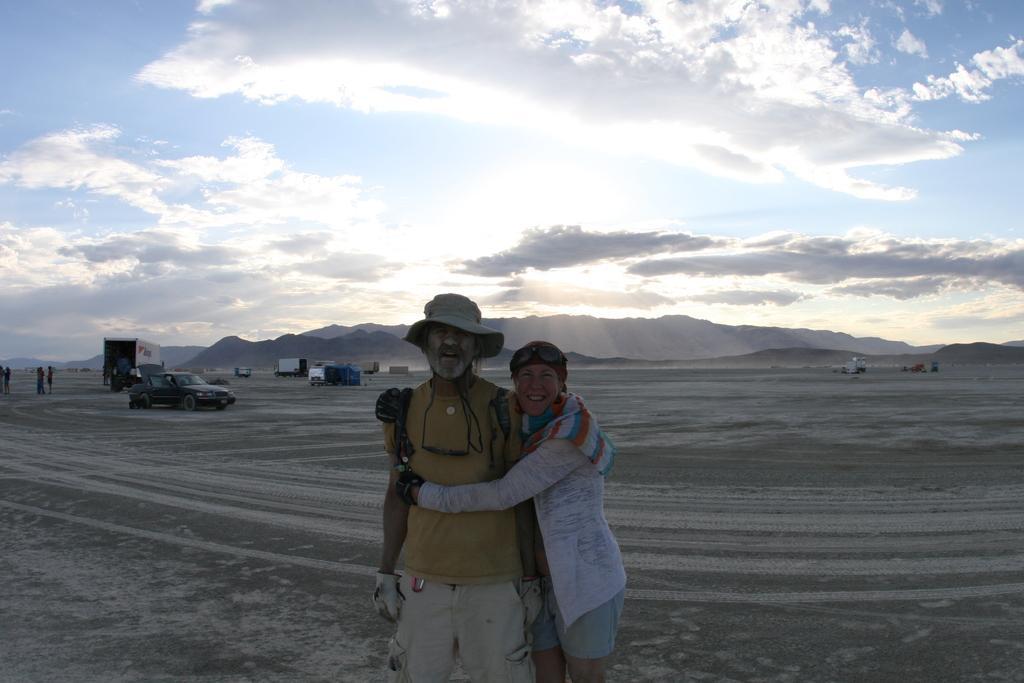Could you give a brief overview of what you see in this image? The man in yellow T-shirt is standing beside the woman who is wearing a white dress. Both of them are smiling. Behind them, we see vehicles which are parked. On the left side, we see people standing. At the bottom of the picture, we see the sand. In the background, there are hills. At the top of the picture, we see the sky, clouds and the sun. 